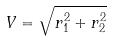Convert formula to latex. <formula><loc_0><loc_0><loc_500><loc_500>V = \sqrt { r _ { 1 } ^ { 2 } + r _ { 2 } ^ { 2 } }</formula> 